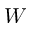Convert formula to latex. <formula><loc_0><loc_0><loc_500><loc_500>W</formula> 